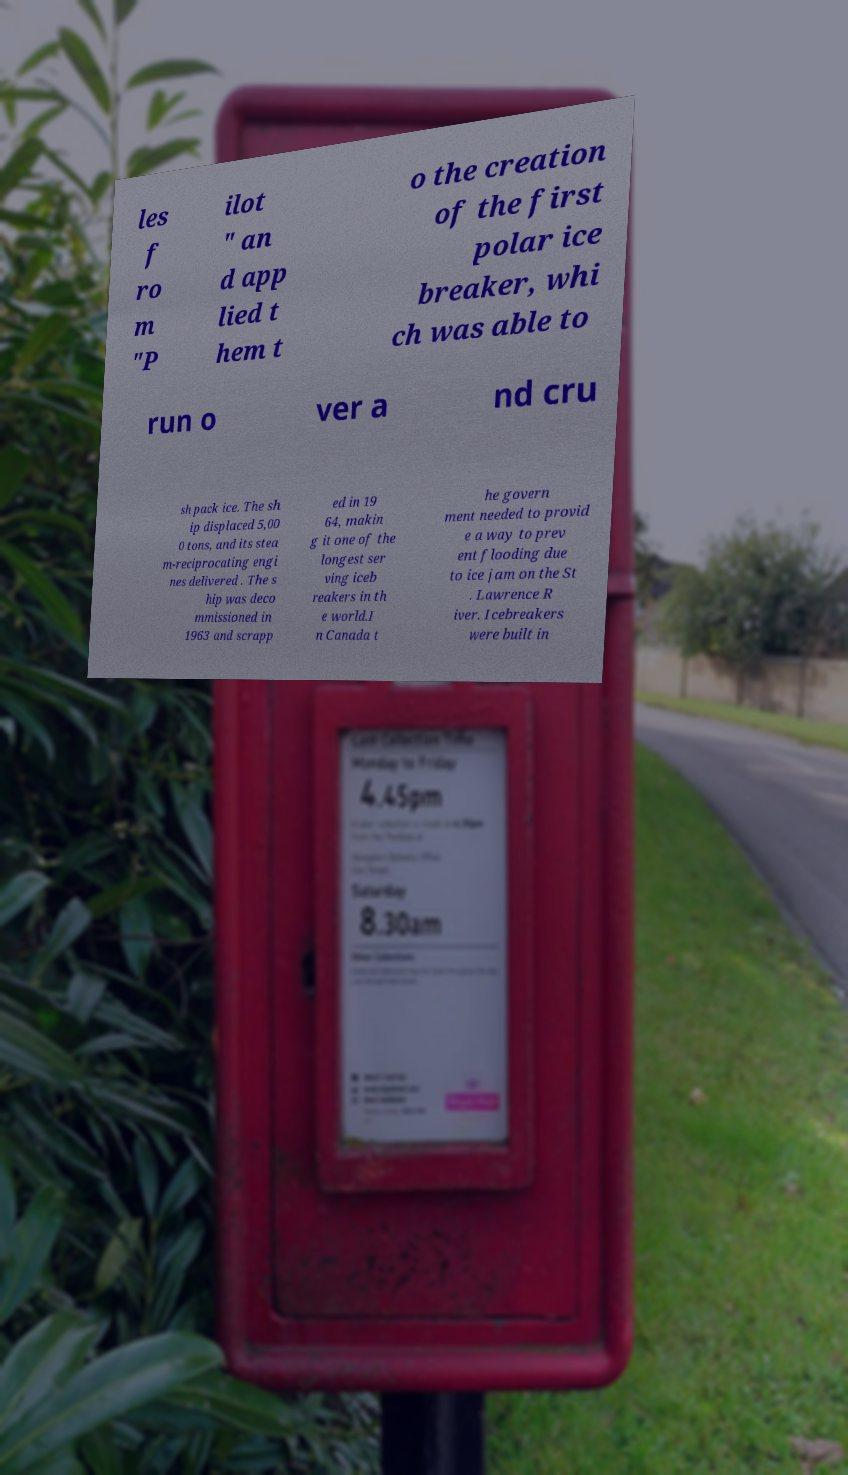Can you read and provide the text displayed in the image?This photo seems to have some interesting text. Can you extract and type it out for me? les f ro m "P ilot " an d app lied t hem t o the creation of the first polar ice breaker, whi ch was able to run o ver a nd cru sh pack ice. The sh ip displaced 5,00 0 tons, and its stea m-reciprocating engi nes delivered . The s hip was deco mmissioned in 1963 and scrapp ed in 19 64, makin g it one of the longest ser ving iceb reakers in th e world.I n Canada t he govern ment needed to provid e a way to prev ent flooding due to ice jam on the St . Lawrence R iver. Icebreakers were built in 